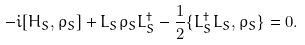Convert formula to latex. <formula><loc_0><loc_0><loc_500><loc_500>- i [ H _ { S } , \rho _ { S } ] + L _ { S } \rho _ { S } L _ { S } ^ { \dag } - \frac { 1 } { 2 } \{ L _ { S } ^ { \dag } L _ { S } , \rho _ { S } \} = 0 .</formula> 